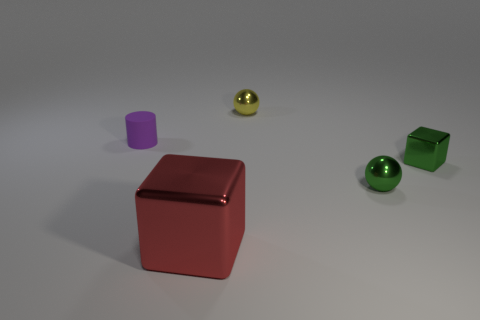The tiny thing to the left of the cube that is on the left side of the yellow thing is made of what material? The small purple cylinder to the left of the red cube, which in turn is to the left of the yellow sphere, appears to be made of a matte plastic material. 